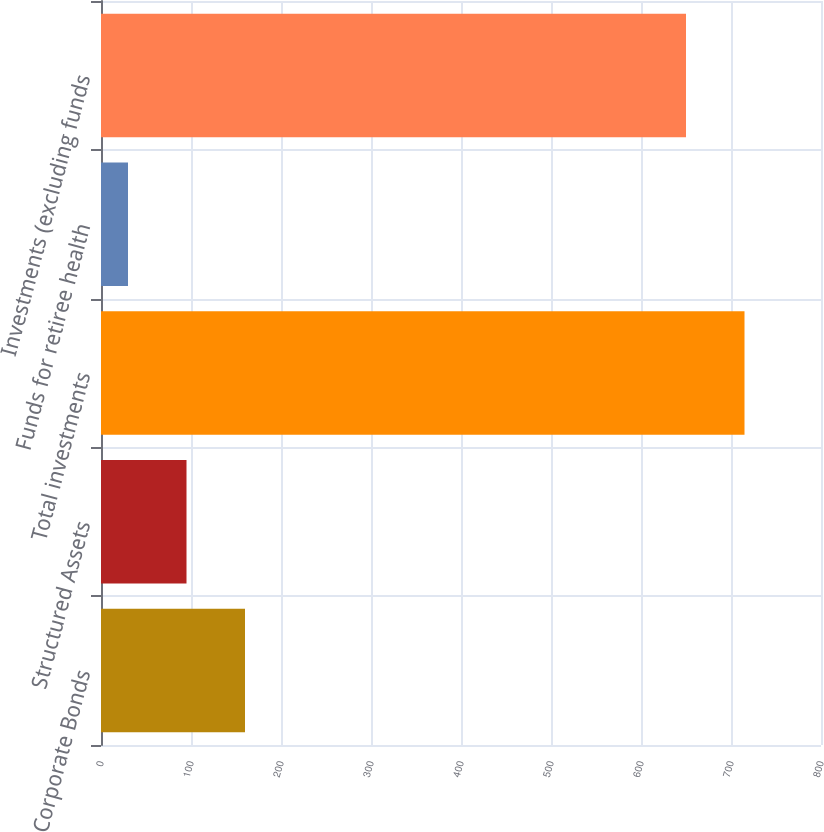Convert chart. <chart><loc_0><loc_0><loc_500><loc_500><bar_chart><fcel>Corporate Bonds<fcel>Structured Assets<fcel>Total investments<fcel>Funds for retiree health<fcel>Investments (excluding funds<nl><fcel>160<fcel>95<fcel>715<fcel>30<fcel>650<nl></chart> 